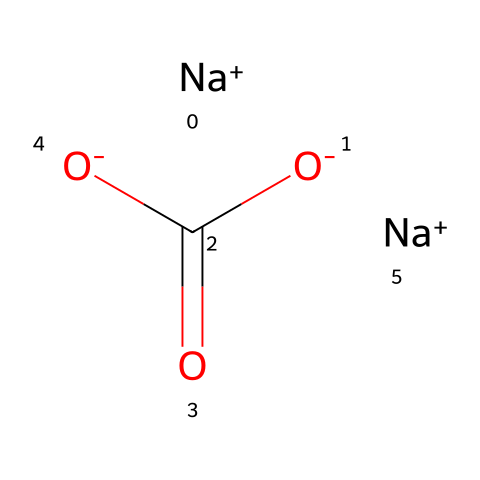What is the primary cation found in natron? The cation represented in the SMILES structure is sodium (Na+), as indicated by the presence of "[Na+]" at the beginning and end of the representation, which indicates it is a positively charged ion.
Answer: sodium How many carbon atoms are present in natron? The SMILES representation shows one carbon atom in the structure "C(=O)", which indicates that carbon is part of a carboxylate (COO-) group.
Answer: one What type of chemical bond connects the sodium ions to the rest of the molecule? The sodium ions ([Na+]) are typically associated with ionic bonds due to their positive charge, which indicates they interact electrostatically with the negatively charged parts of the molecule, like the carboxylate ion (COO-).
Answer: ionic What functional group is present in natron? The molecule includes a carboxylate ion (represented as "C(=O)[O-]"), which is indicative of the carboxylic acid functional group but here exists as its deprotonated form (carboxylate).
Answer: carboxylate What is the total charge of the natron molecule? The molecule has two sodium cations, each with a charge of +1, and one carboxylate with a charge of -1, leading to a total of +1 from Na+ ions and -1 from the carboxylate, resulting in a neutral overall charge.
Answer: zero How does natron contribute to the preservation during mummification? Natron, which contains sodium, acts as a desiccant and absorbs moisture, which is crucial for preventing decomposition and aiding in the preservation process during mummification.
Answer: desiccant 